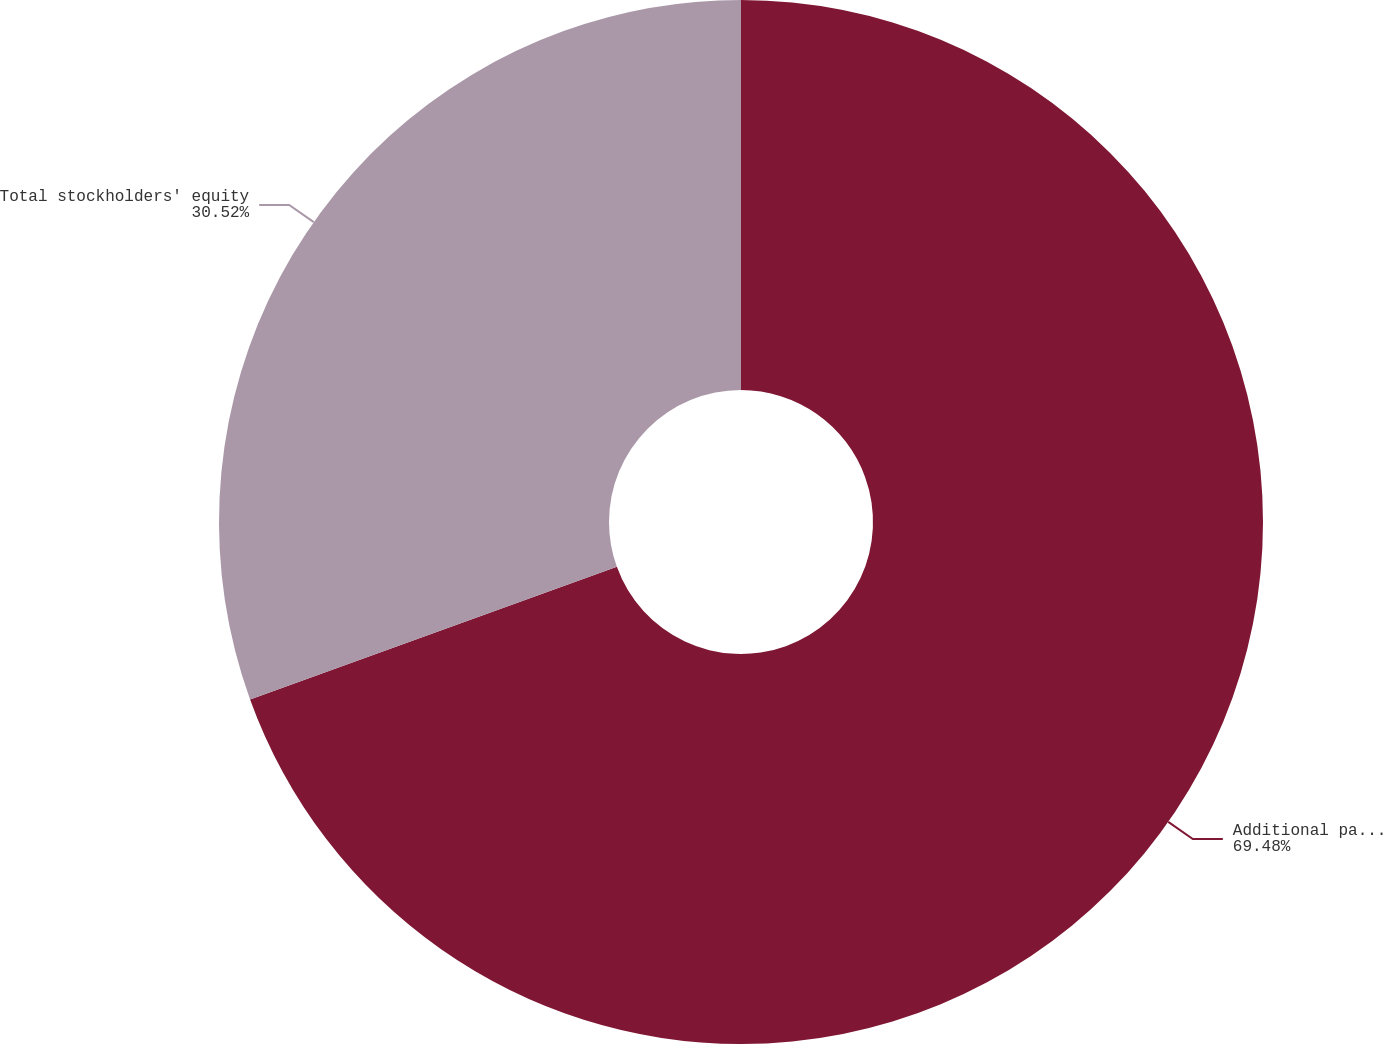Convert chart to OTSL. <chart><loc_0><loc_0><loc_500><loc_500><pie_chart><fcel>Additional paid-in capital<fcel>Total stockholders' equity<nl><fcel>69.48%<fcel>30.52%<nl></chart> 